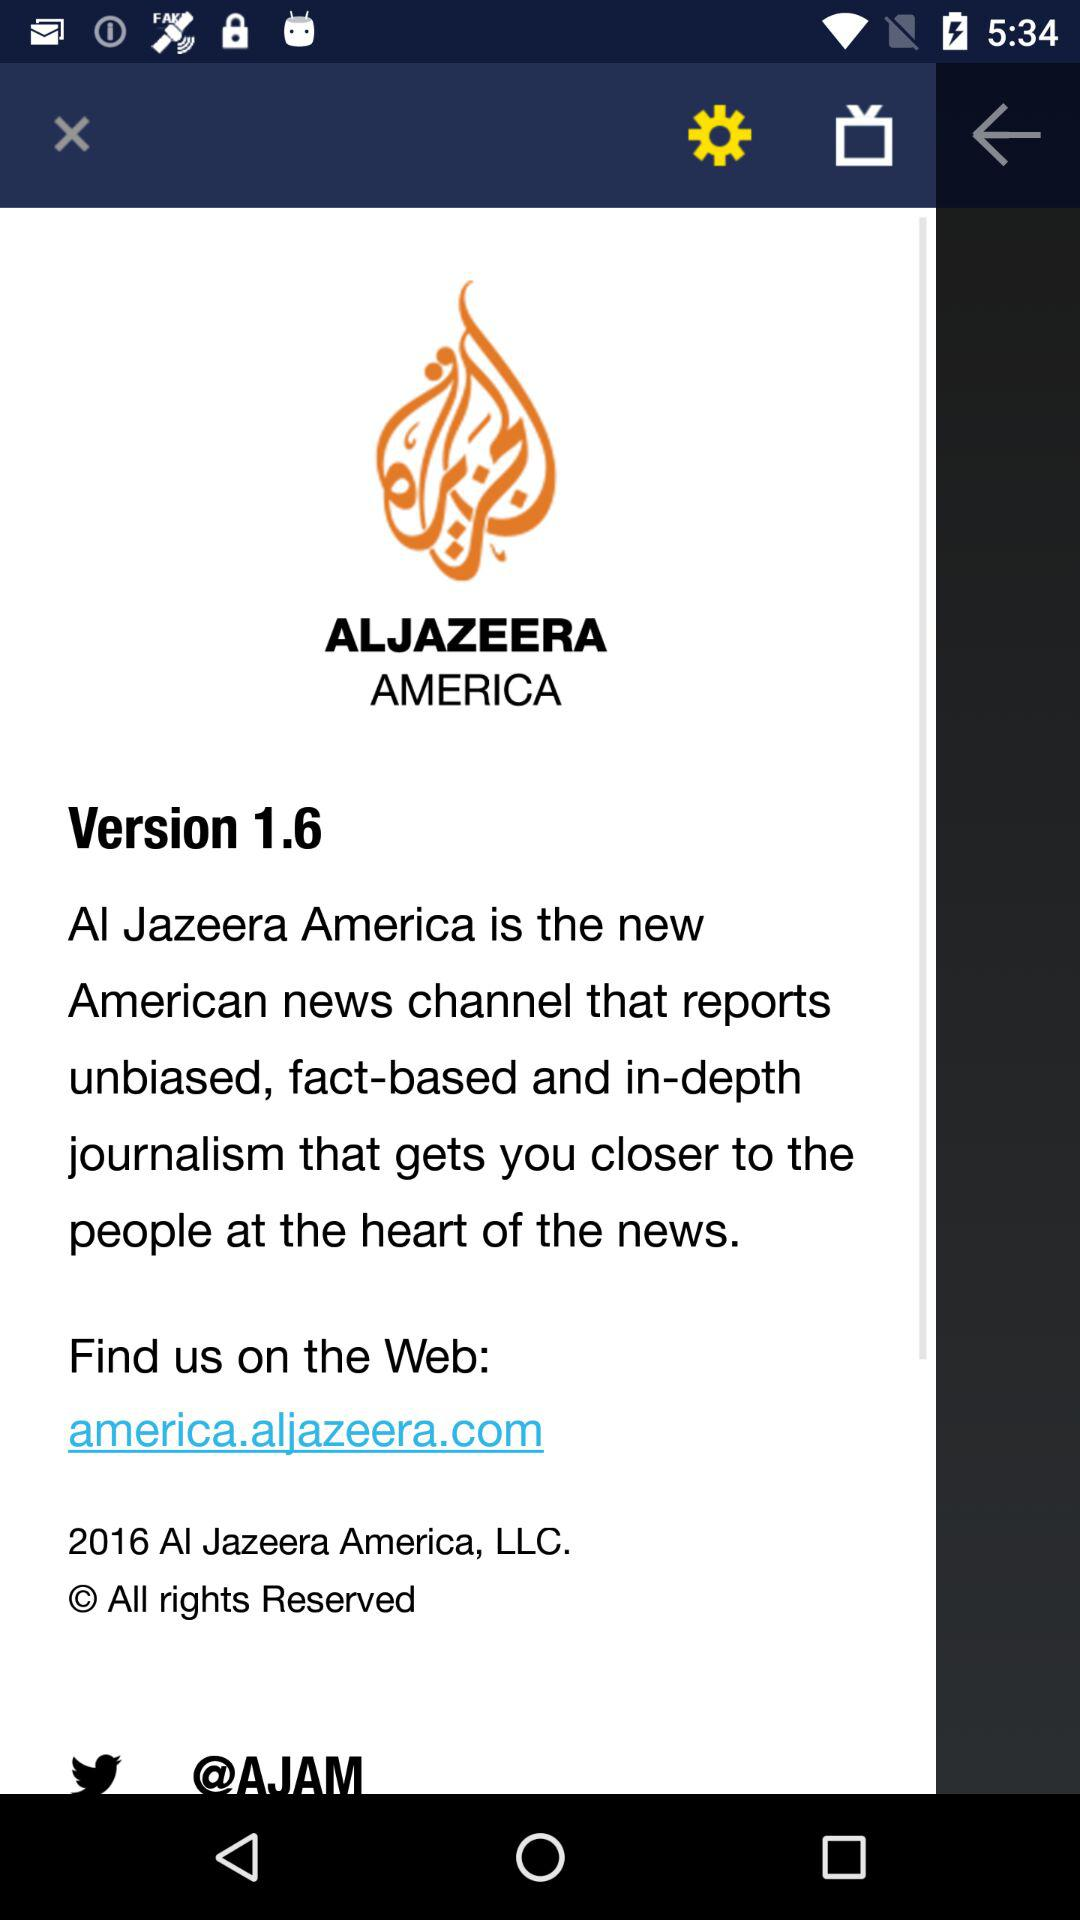What is the application name? The application name is "ALJAZEERA AMERICA". 